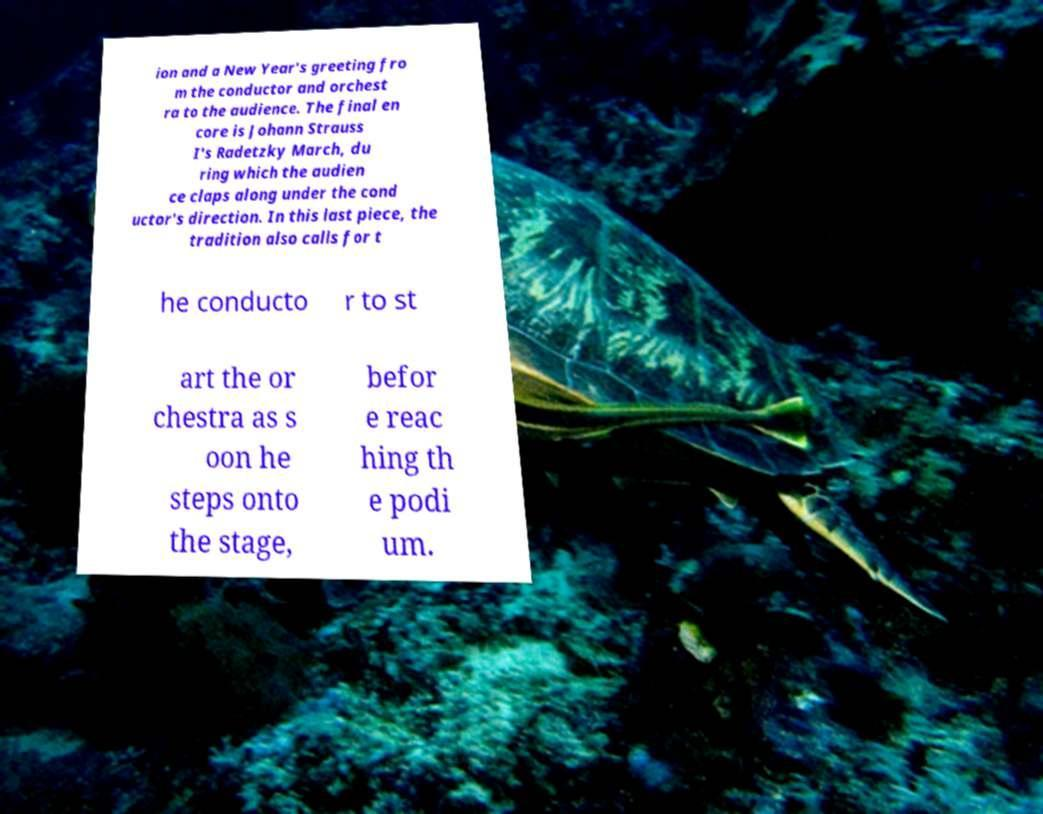Could you extract and type out the text from this image? ion and a New Year's greeting fro m the conductor and orchest ra to the audience. The final en core is Johann Strauss I's Radetzky March, du ring which the audien ce claps along under the cond uctor's direction. In this last piece, the tradition also calls for t he conducto r to st art the or chestra as s oon he steps onto the stage, befor e reac hing th e podi um. 